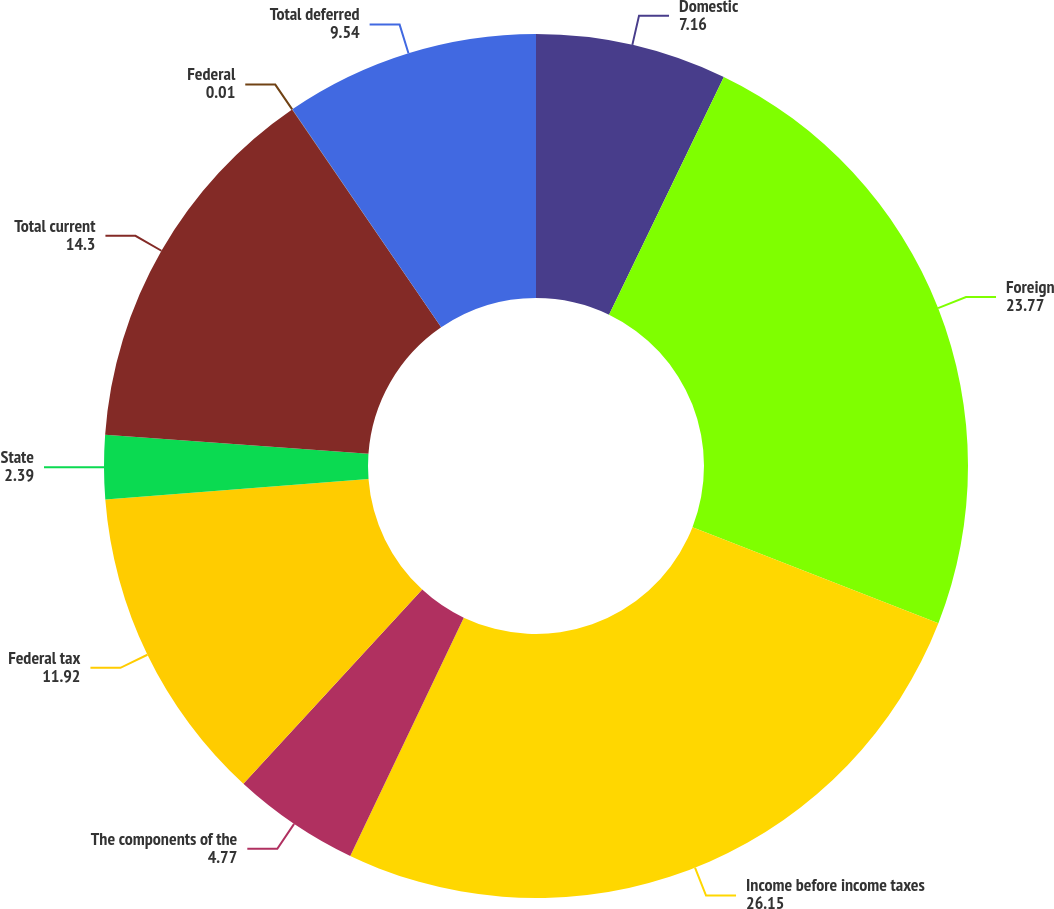<chart> <loc_0><loc_0><loc_500><loc_500><pie_chart><fcel>Domestic<fcel>Foreign<fcel>Income before income taxes<fcel>The components of the<fcel>Federal tax<fcel>State<fcel>Total current<fcel>Federal<fcel>Total deferred<nl><fcel>7.16%<fcel>23.77%<fcel>26.15%<fcel>4.77%<fcel>11.92%<fcel>2.39%<fcel>14.3%<fcel>0.01%<fcel>9.54%<nl></chart> 